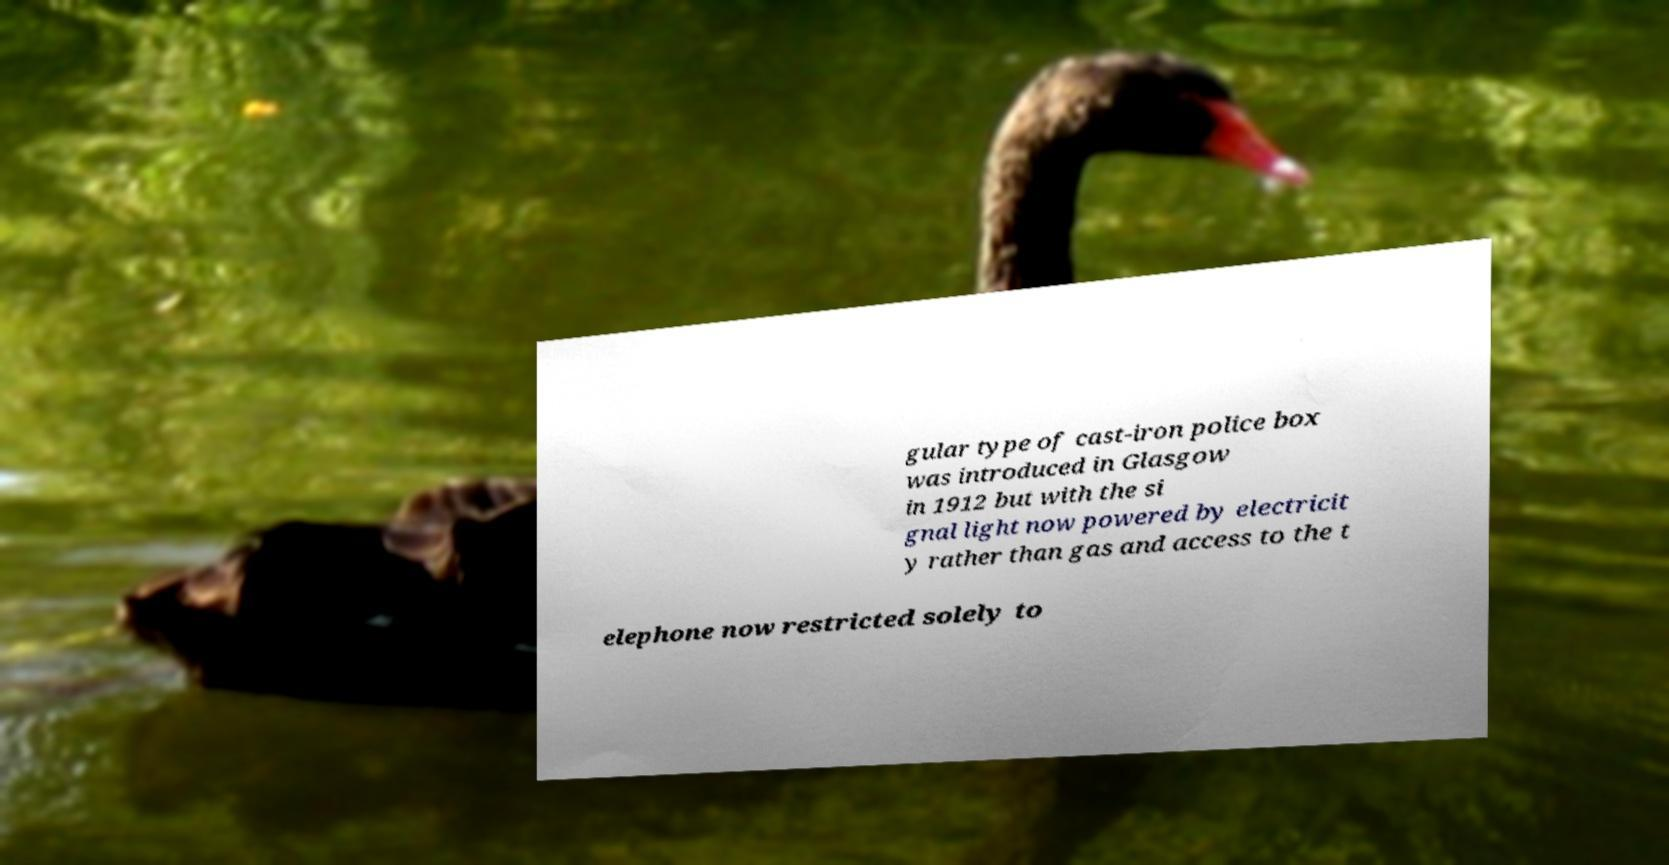Could you extract and type out the text from this image? gular type of cast-iron police box was introduced in Glasgow in 1912 but with the si gnal light now powered by electricit y rather than gas and access to the t elephone now restricted solely to 